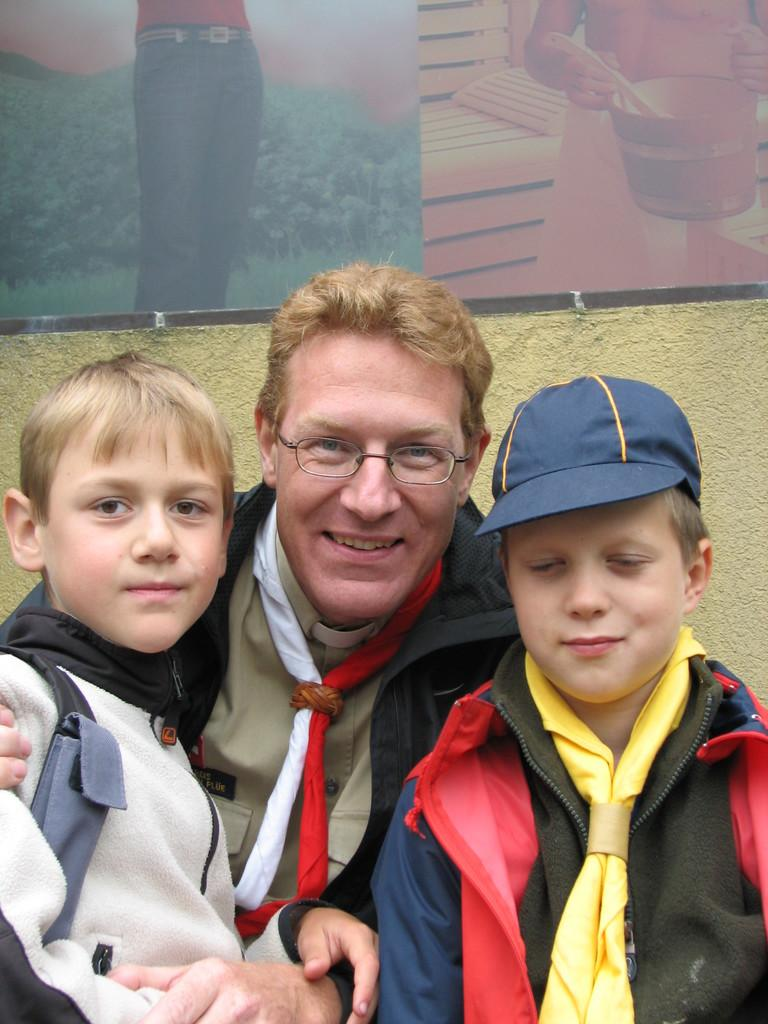How many people are present in the image? There are three people in the image. Can you describe the facial expression of the man in the center? The man sitting in the center is smiling. What can be seen on the head of the boy on the left? The boy on the left is wearing a cap. What is located on the wall in the background? There is a frame placed on the wall in the background. How many dolls are sitting on the floor in the image? There are no dolls present in the image. What type of seed is being planted by the man in the center? There is no seed or planting activity depicted in the image. 